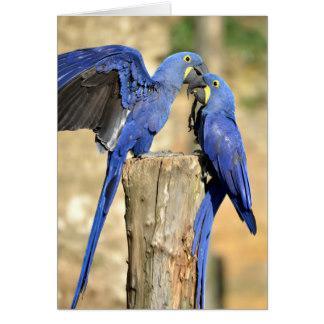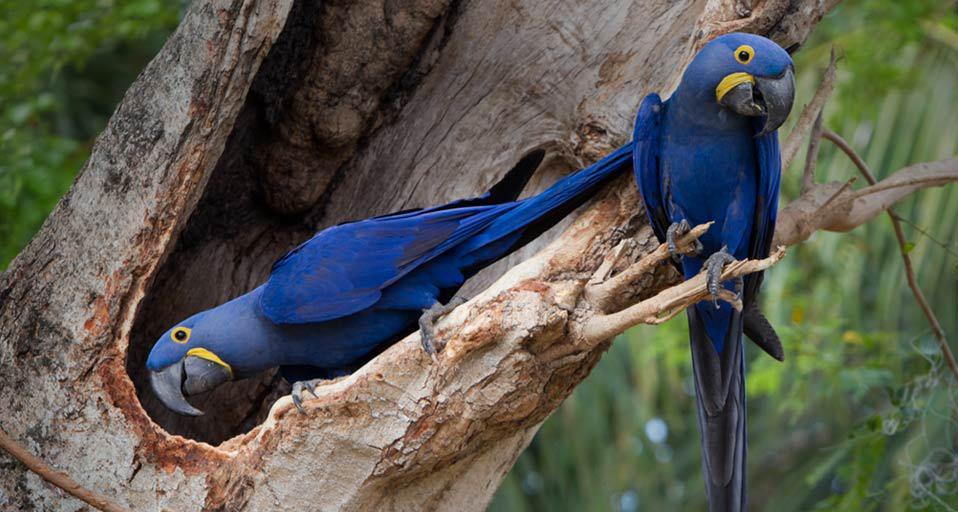The first image is the image on the left, the second image is the image on the right. Given the left and right images, does the statement "One image contains twice as many blue parrots as the other image, and an image shows two birds perched on something made of wood." hold true? Answer yes or no. No. The first image is the image on the left, the second image is the image on the right. Evaluate the accuracy of this statement regarding the images: "There are three blue parrots.". Is it true? Answer yes or no. No. 